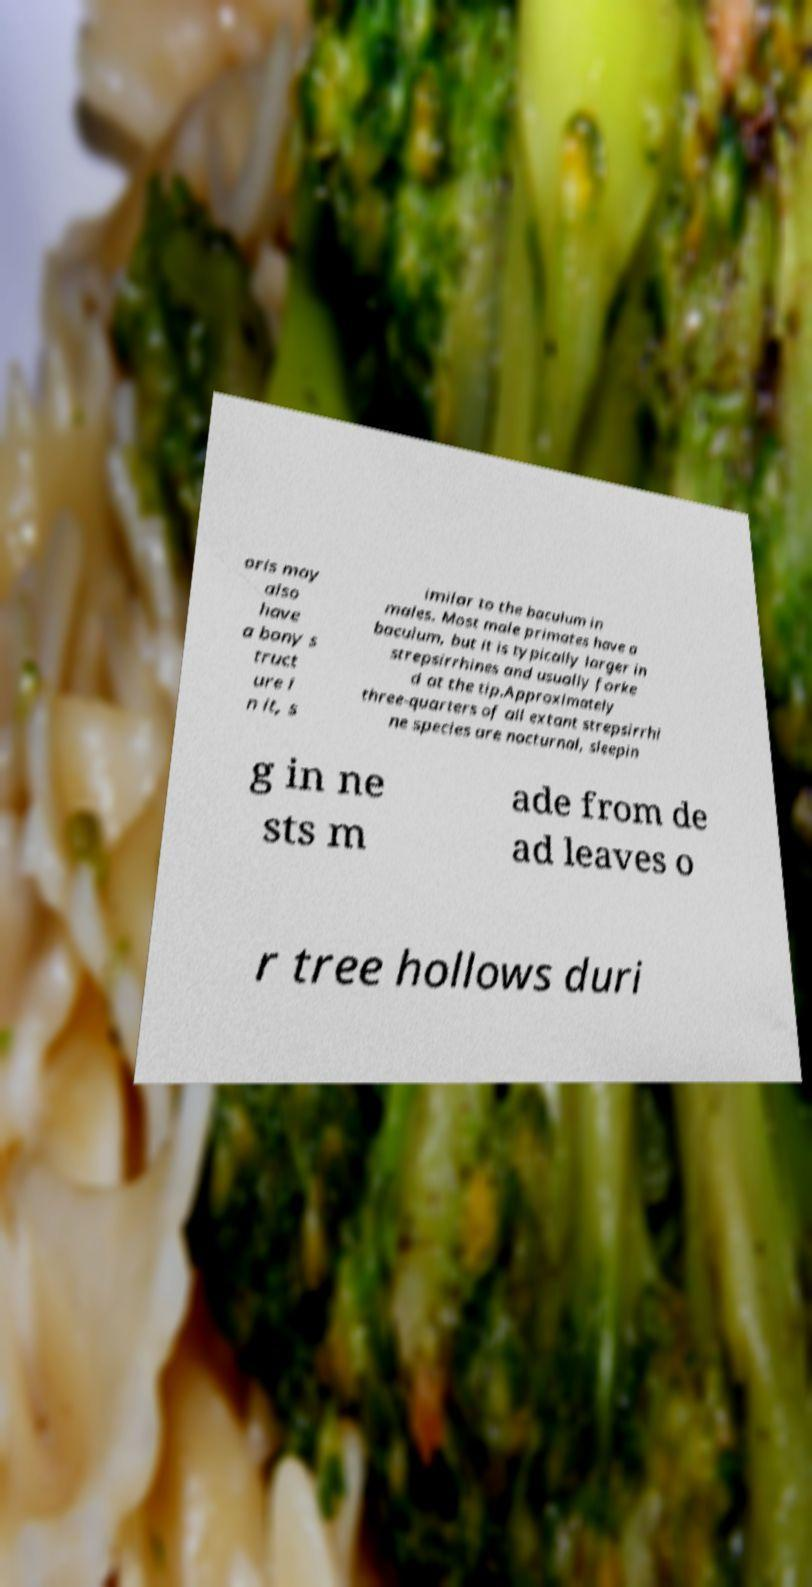Could you assist in decoding the text presented in this image and type it out clearly? oris may also have a bony s truct ure i n it, s imilar to the baculum in males. Most male primates have a baculum, but it is typically larger in strepsirrhines and usually forke d at the tip.Approximately three-quarters of all extant strepsirrhi ne species are nocturnal, sleepin g in ne sts m ade from de ad leaves o r tree hollows duri 